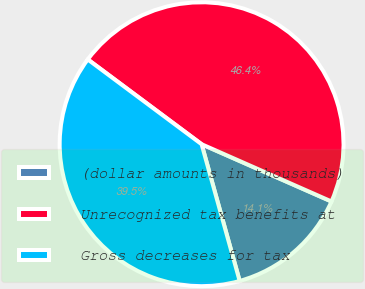Convert chart to OTSL. <chart><loc_0><loc_0><loc_500><loc_500><pie_chart><fcel>(dollar amounts in thousands)<fcel>Unrecognized tax benefits at<fcel>Gross decreases for tax<nl><fcel>14.07%<fcel>46.42%<fcel>39.51%<nl></chart> 